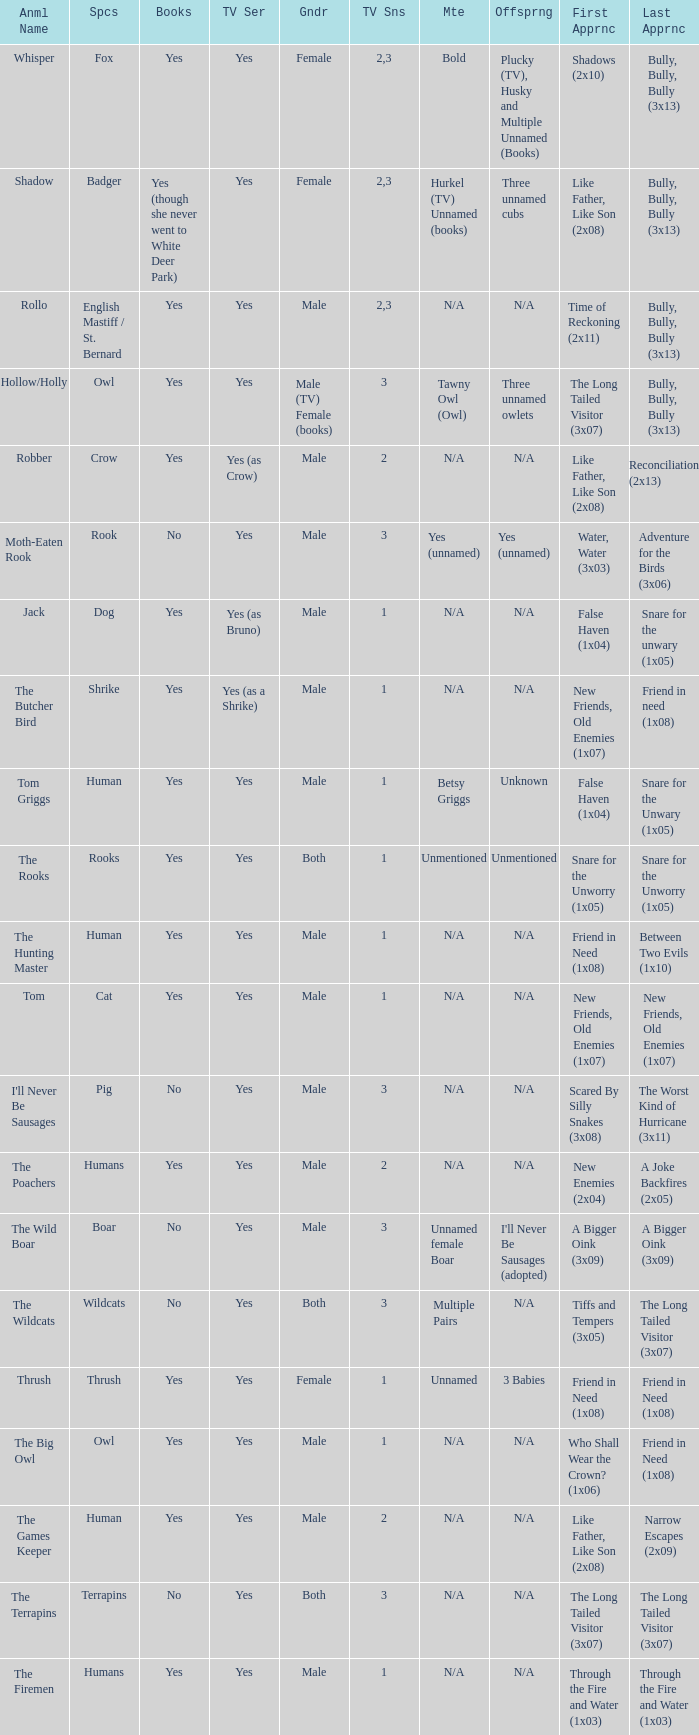What animal was yes for tv series and was a terrapins? The Terrapins. 